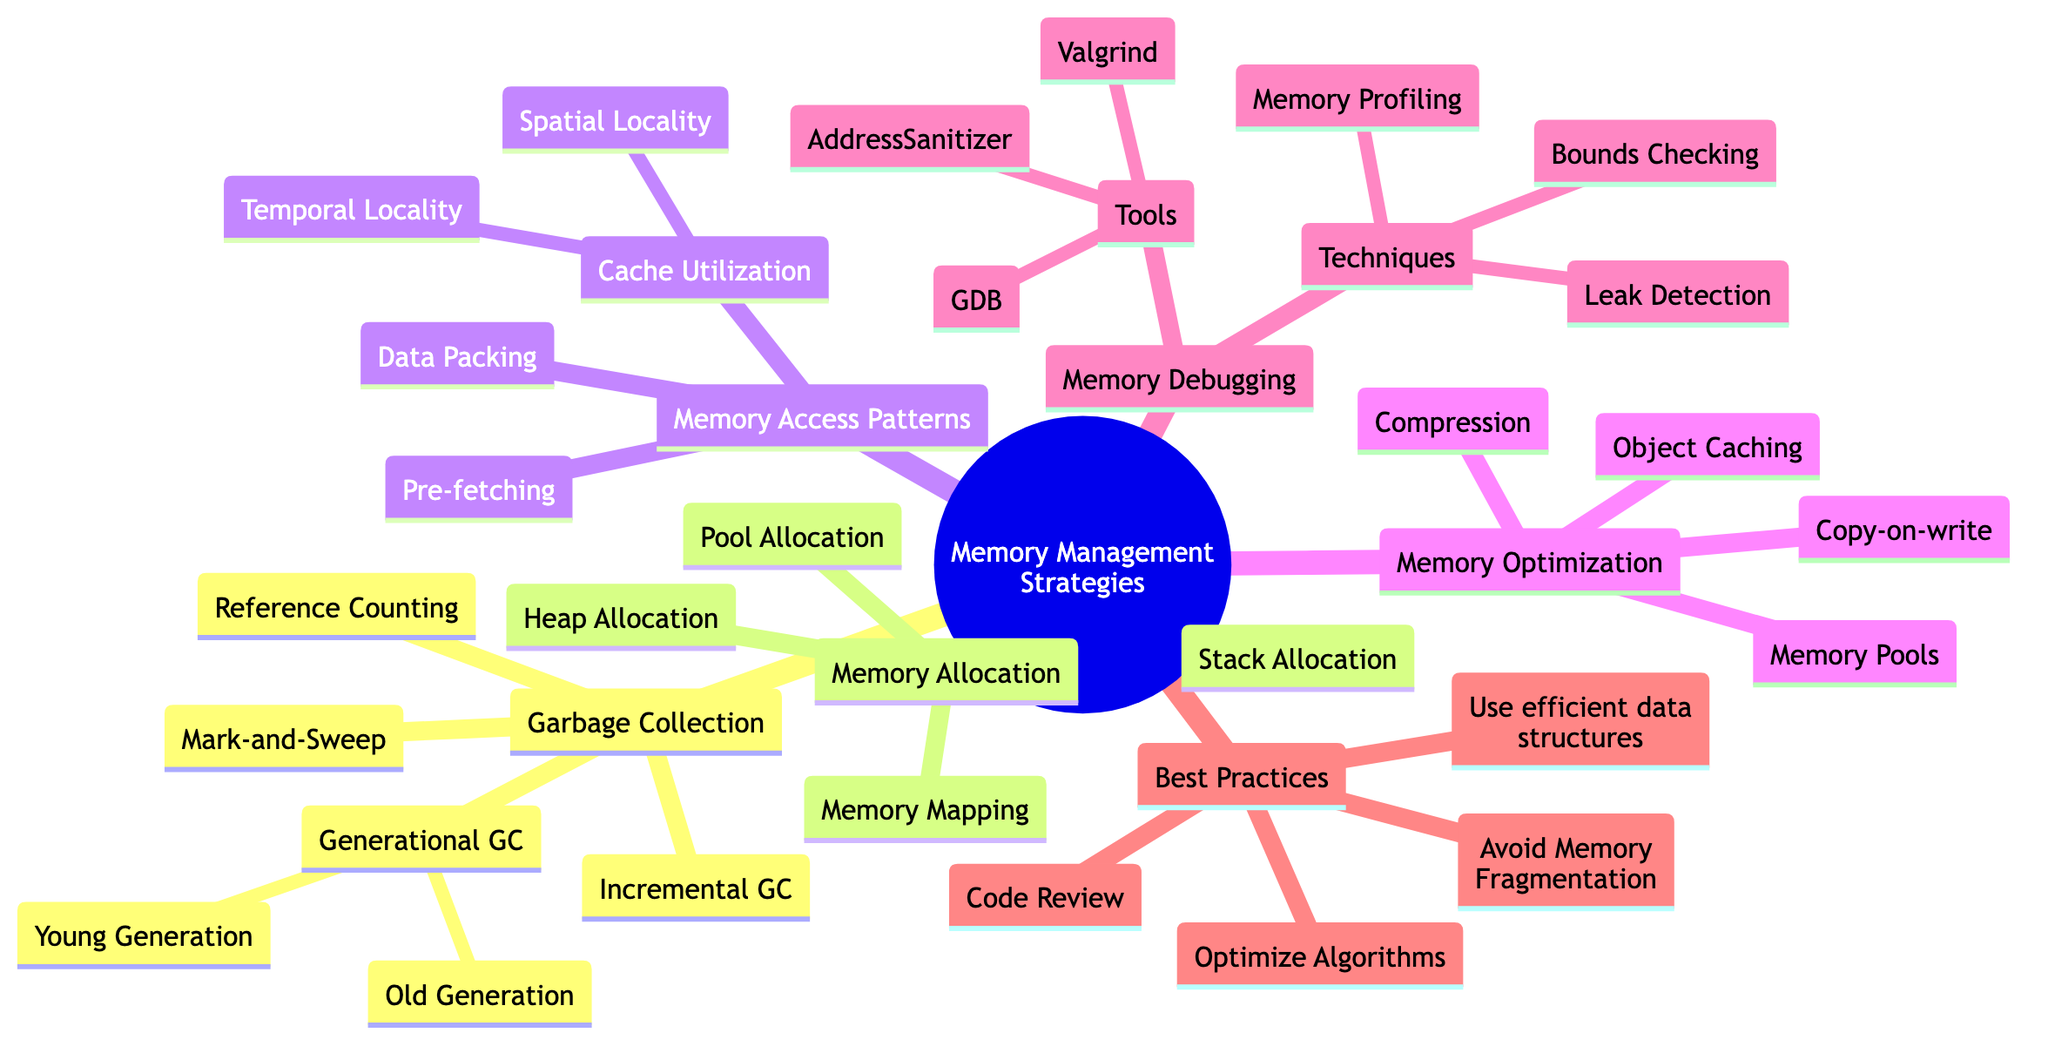What is the main topic of the mind map? The central theme of the diagram is indicated at the root node, which is labeled "Memory Management Strategies."
Answer: Memory Management Strategies How many main categories are there under "Memory Management Strategies"? There are five main categories branching out from the root node: Garbage Collection, Memory Allocation, Memory Access Patterns, Memory Optimization, and Memory Debugging.
Answer: 5 What is one method listed under "Garbage Collection"? The diagram includes several methods under Garbage Collection, one of which is "Reference Counting."
Answer: Reference Counting What strategy is indicated for "Memory Allocation"? One of the strategies specified under Memory Allocation is "Heap Allocation."
Answer: Heap Allocation Which technique helps in analyzing memory usage? The diagram specifies "Memory Profiling" as a technique under Memory Debugging focused on analyzing memory usage.
Answer: Memory Profiling What does "Copy-on-write" optimize? "Copy-on-write" is specified under Memory Optimization, and it is used to optimize data sharing.
Answer: Data sharing How many tools are listed under "Memory Debugging"? The diagram mentions three tools under Memory Debugging: Valgrind, AddressSanitizer, and GDB.
Answer: 3 What can help avoid memory fragmentation? The diagram indicates that avoiding memory fragmentation can be achieved through "Manage allocation strategies," which is a best practice.
Answer: Manage allocation strategies What is an effect of "Cache Utilization" from "Memory Access Patterns"? "Cache Utilization" includes "Spatial Locality," which relates to accessing contiguous memory locations, thereby improving efficiency.
Answer: Access contiguous memory locations 